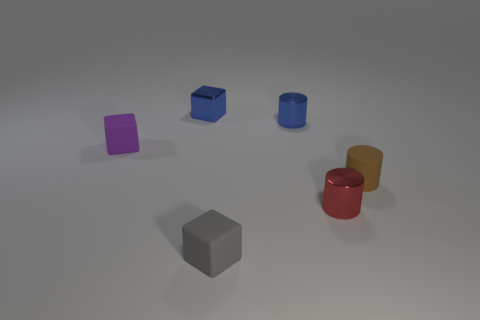Subtract all blue cylinders. How many cylinders are left? 2 Add 2 tiny brown cubes. How many objects exist? 8 Subtract all metallic cubes. Subtract all matte blocks. How many objects are left? 3 Add 5 tiny brown objects. How many tiny brown objects are left? 6 Add 4 red metal cylinders. How many red metal cylinders exist? 5 Subtract 0 red balls. How many objects are left? 6 